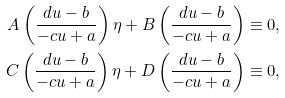<formula> <loc_0><loc_0><loc_500><loc_500>A \left ( \frac { d u - b } { - c u + a } \right ) \eta + B \left ( \frac { d u - b } { - c u + a } \right ) & \equiv 0 , \\ C \left ( \frac { d u - b } { - c u + a } \right ) \eta + D \left ( \frac { d u - b } { - c u + a } \right ) & \equiv 0 ,</formula> 